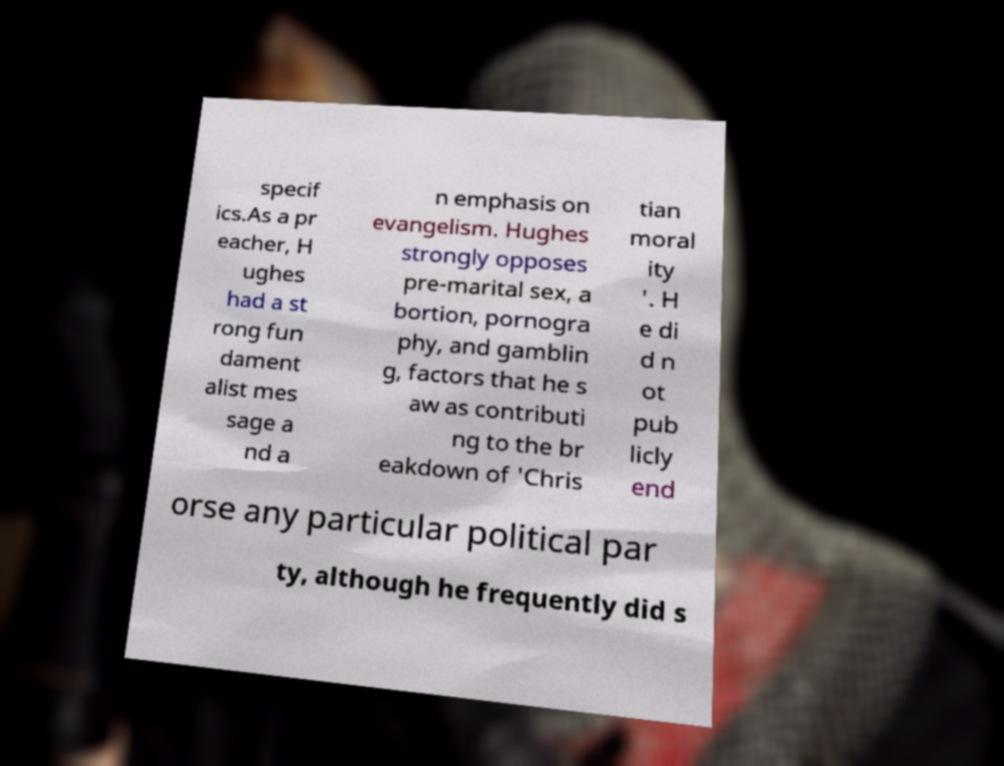For documentation purposes, I need the text within this image transcribed. Could you provide that? specif ics.As a pr eacher, H ughes had a st rong fun dament alist mes sage a nd a n emphasis on evangelism. Hughes strongly opposes pre-marital sex, a bortion, pornogra phy, and gamblin g, factors that he s aw as contributi ng to the br eakdown of 'Chris tian moral ity '. H e di d n ot pub licly end orse any particular political par ty, although he frequently did s 